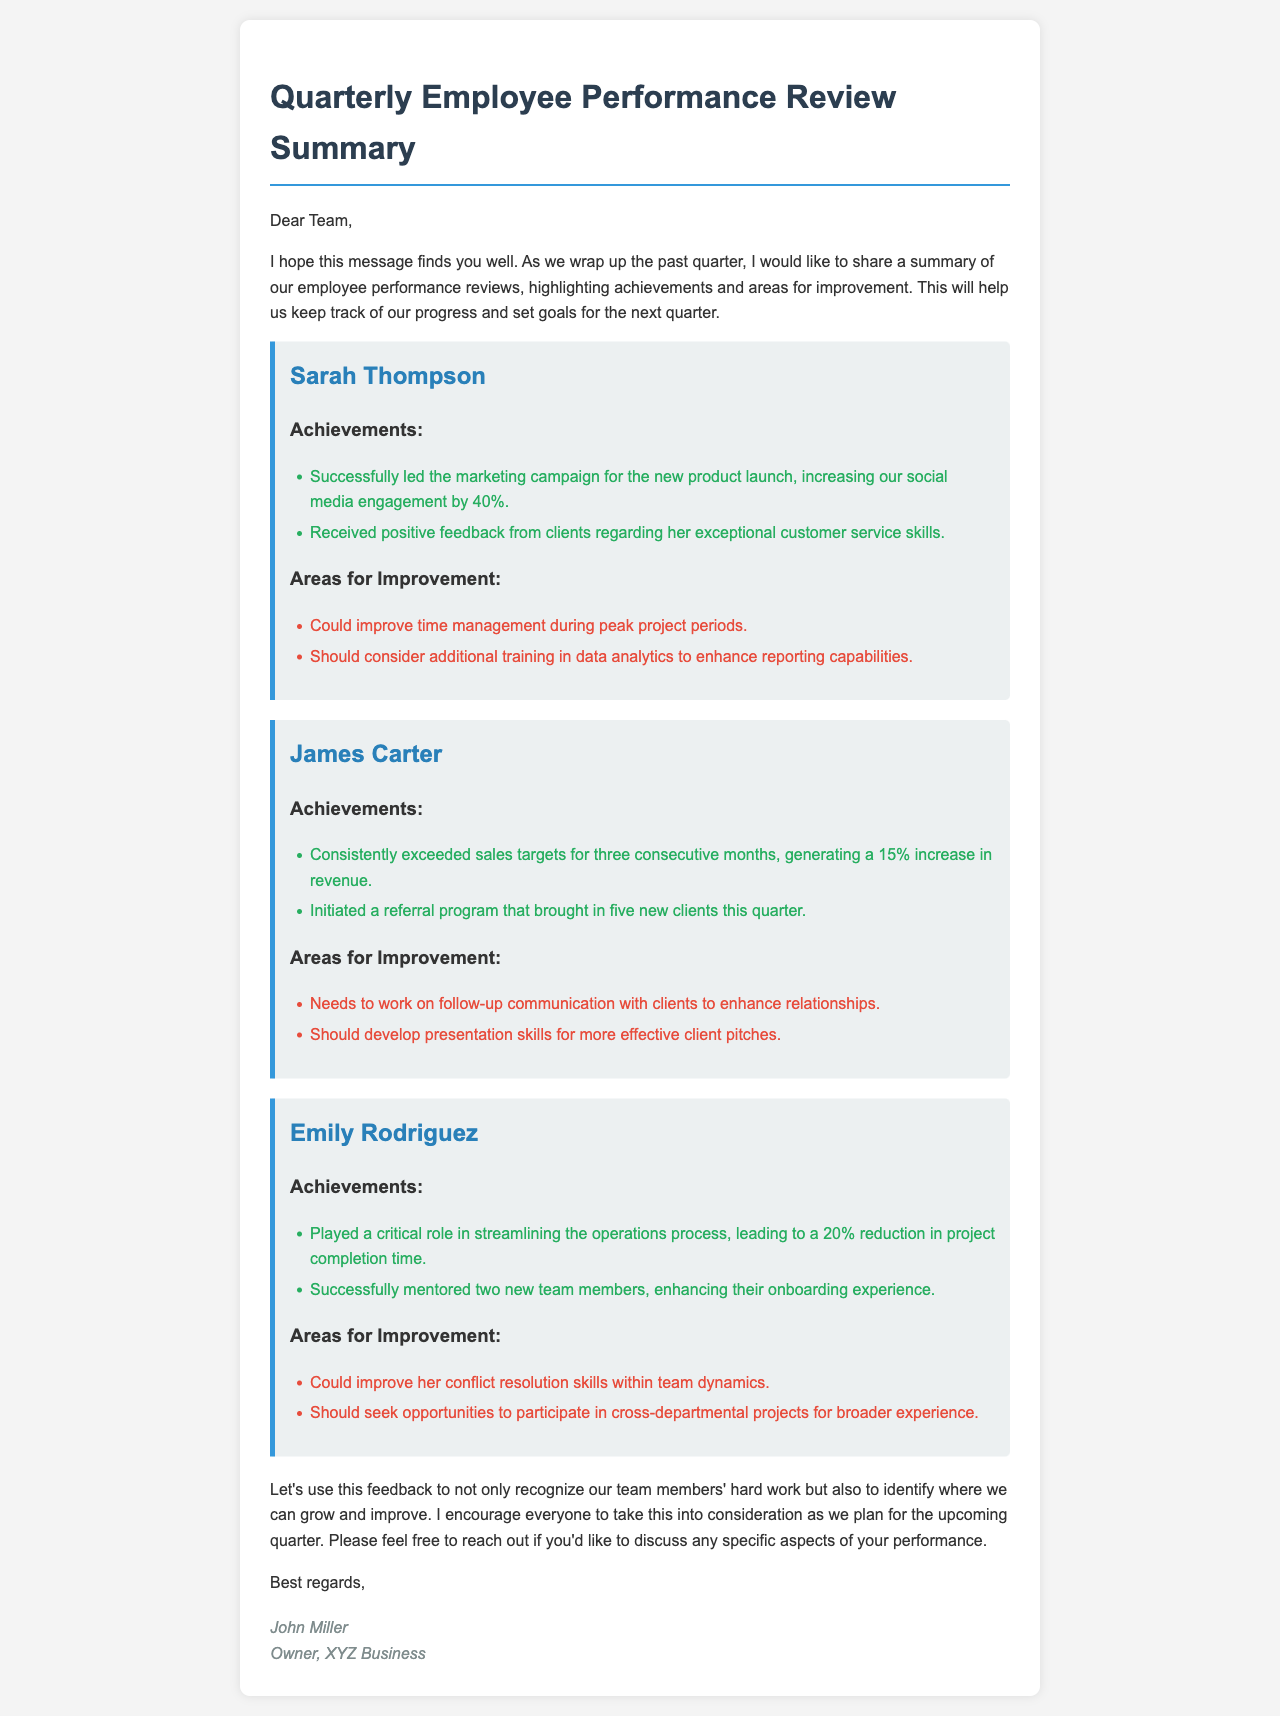What are Sarah Thompson's achievements? Sarah Thompson's achievements include leading a marketing campaign and receiving positive client feedback.
Answer: Successfully led the marketing campaign for the new product launch, increasing our social media engagement by 40%. Received positive feedback from clients regarding her exceptional customer service skills What is James Carter's sales increase percentage? James Carter's sales increase percentage is provided in the document as a specific figure resulting from his performance.
Answer: 15% What skills should Emily Rodriguez improve? The document lists specific areas for improvement for Emily Rodriguez.
Answer: Conflict resolution skills, broader experience Who initiated a referral program? The document specifies which employee took the initiative to start a referral program.
Answer: James Carter How many new clients did the referral program bring in? The number of new clients mentioned in the context of James Carter's achievements is clearly stated in the document.
Answer: Five What did Emily Rodriguez streamline? The document states a specific process that Emily Rodriguez played a critical role in improving.
Answer: Operations process What is the purpose of this email? The document opens with the purpose of the email, reflecting the intent behind sharing the performance reviews.
Answer: To share a summary of employee performance reviews What role did Sarah Thompson play in the marketing campaign? The document describes Sarah Thompson's involvement in a specific campaign, highlighting her responsibilities.
Answer: Led the marketing campaign 